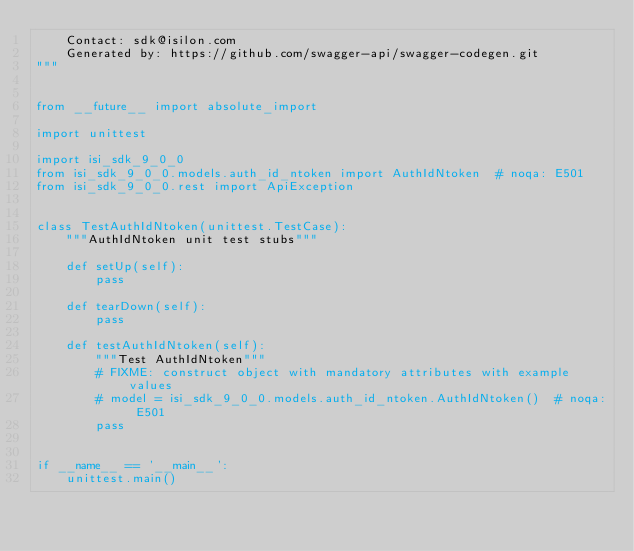<code> <loc_0><loc_0><loc_500><loc_500><_Python_>    Contact: sdk@isilon.com
    Generated by: https://github.com/swagger-api/swagger-codegen.git
"""


from __future__ import absolute_import

import unittest

import isi_sdk_9_0_0
from isi_sdk_9_0_0.models.auth_id_ntoken import AuthIdNtoken  # noqa: E501
from isi_sdk_9_0_0.rest import ApiException


class TestAuthIdNtoken(unittest.TestCase):
    """AuthIdNtoken unit test stubs"""

    def setUp(self):
        pass

    def tearDown(self):
        pass

    def testAuthIdNtoken(self):
        """Test AuthIdNtoken"""
        # FIXME: construct object with mandatory attributes with example values
        # model = isi_sdk_9_0_0.models.auth_id_ntoken.AuthIdNtoken()  # noqa: E501
        pass


if __name__ == '__main__':
    unittest.main()
</code> 